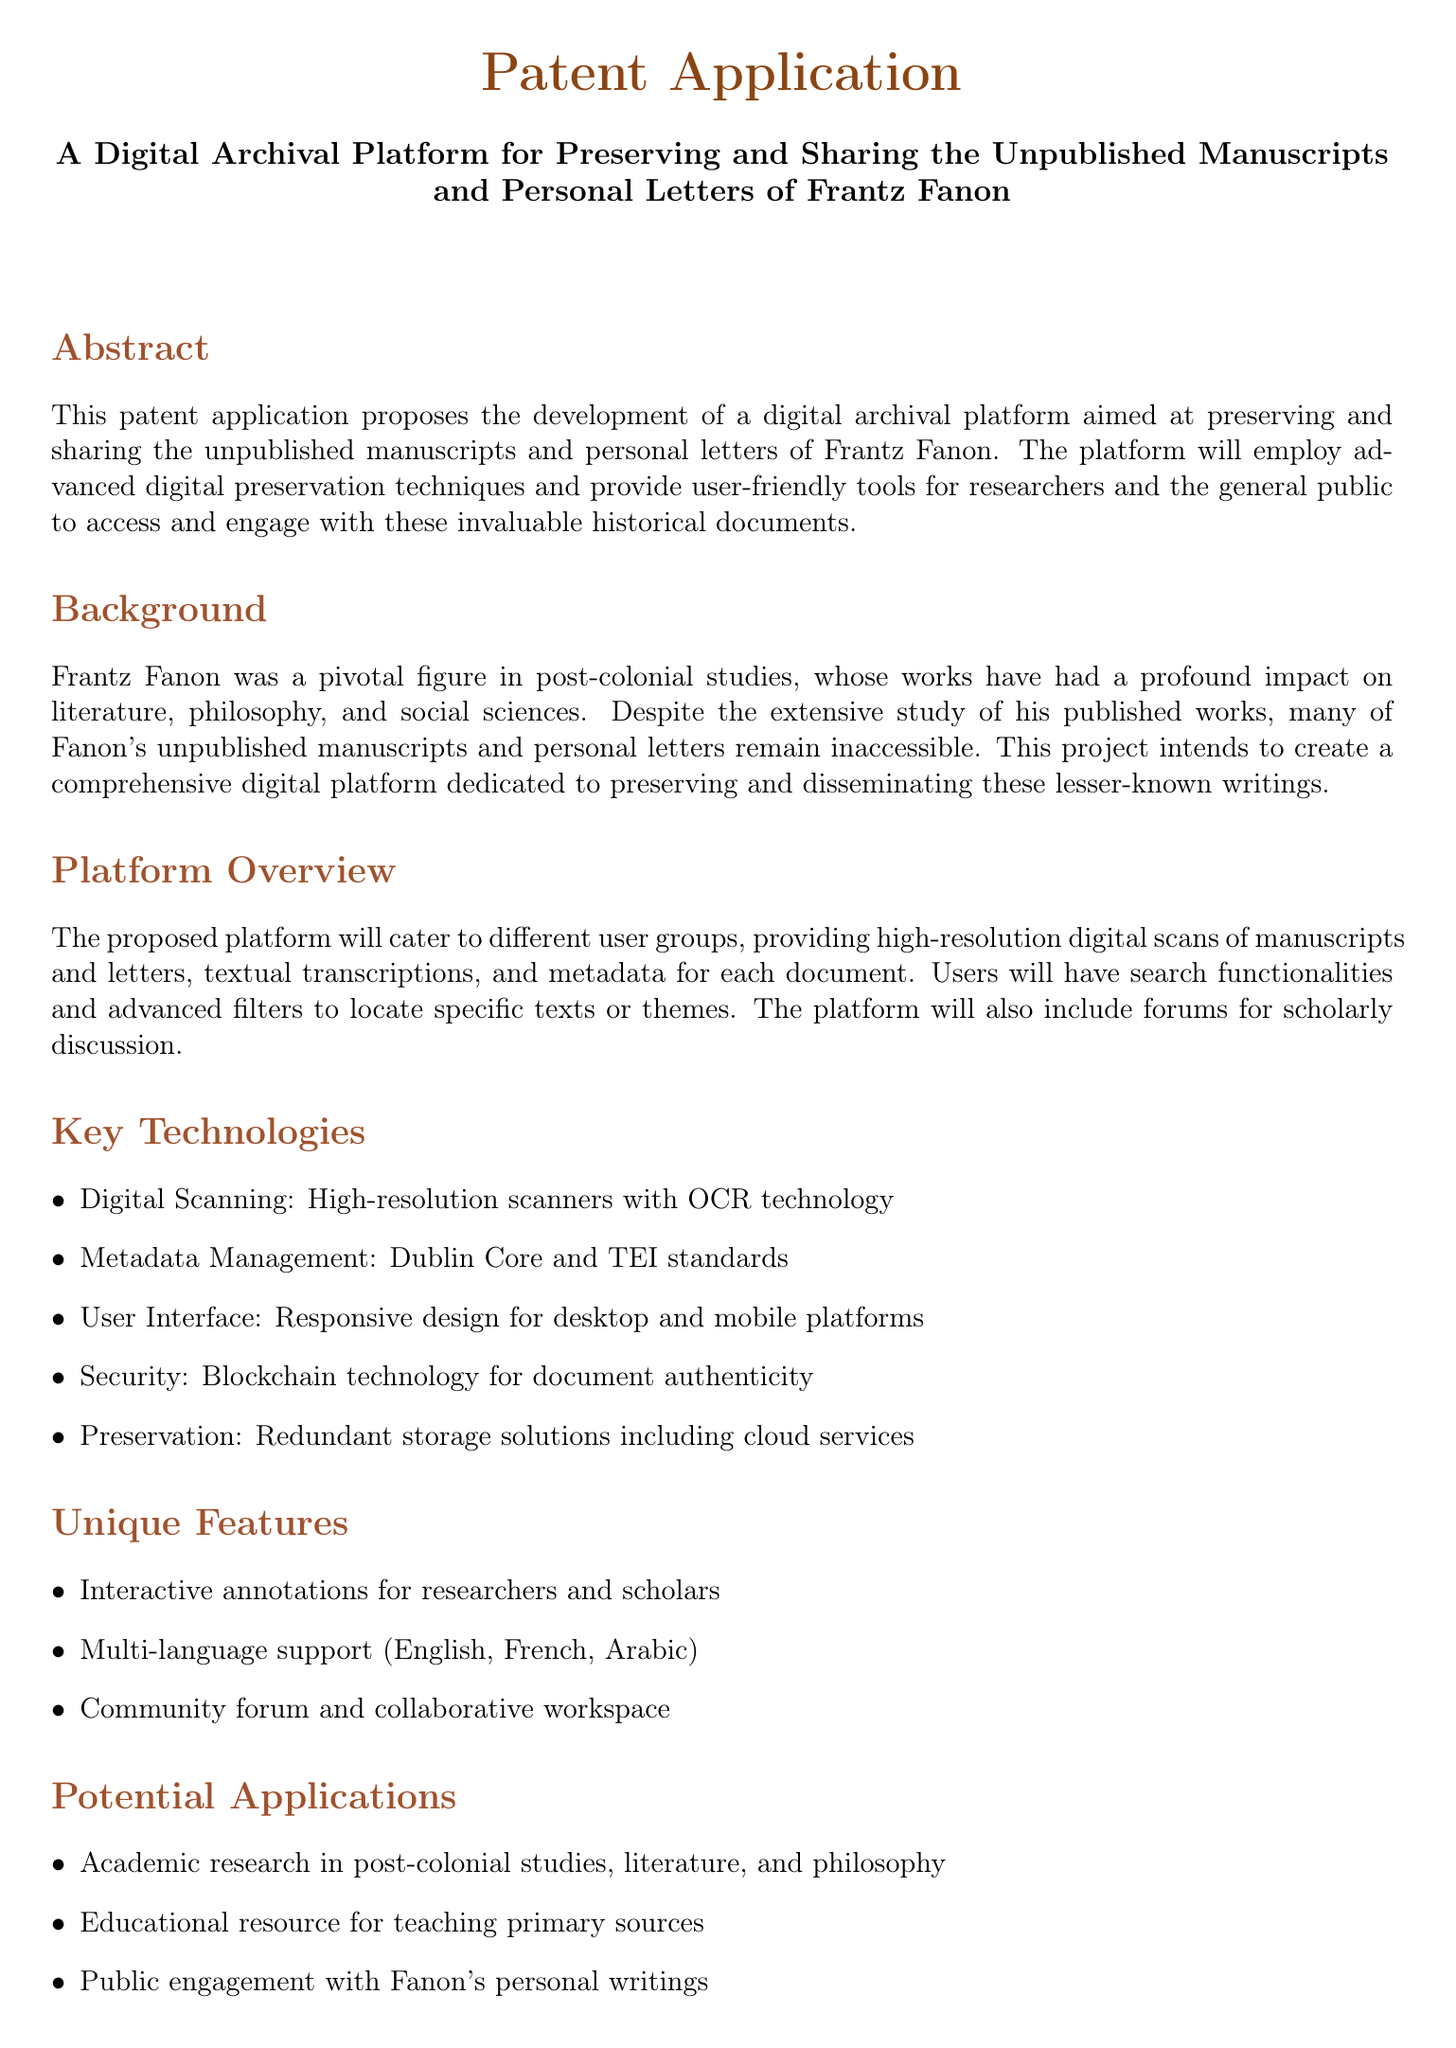what is the title of the patent application? The title is presented prominently at the beginning of the document, summarizing the main focus of the invention.
Answer: A Digital Archival Platform for Preserving and Sharing the Unpublished Manuscripts and Personal Letters of Frantz Fanon who was Frantz Fanon? The document provides background information on Frantz Fanon, highlighting his significance in various academic fields.
Answer: A pivotal figure in post-colonial studies what technology is used for document authentication? This detail is specified under the 'Key Technologies' section, indicating the security measures in place for the platform.
Answer: Blockchain technology how many languages does the platform support? This information can be found in the 'Unique Features' section, specifying the language capabilities of the platform.
Answer: Three what kind of scans will be provided? The document outlines the features of the platform, mentioning the type of digital imagery that users can expect.
Answer: High-resolution digital scans which standards are used for metadata management? This detail is discussed in the 'Key Technologies' section, providing specifics on the metadata standards implemented.
Answer: Dublin Core and TEI standards what is one potential application of the platform? The document lists various applications under the 'Potential Applications' section, focusing on how the platform can be utilized.
Answer: Academic research in post-colonial studies what is an interactive feature mentioned in the document? This refers to a specific feature designed to enhance user engagement with the platform as outlined in the 'Unique Features' section.
Answer: Interactive annotations for researchers and scholars 